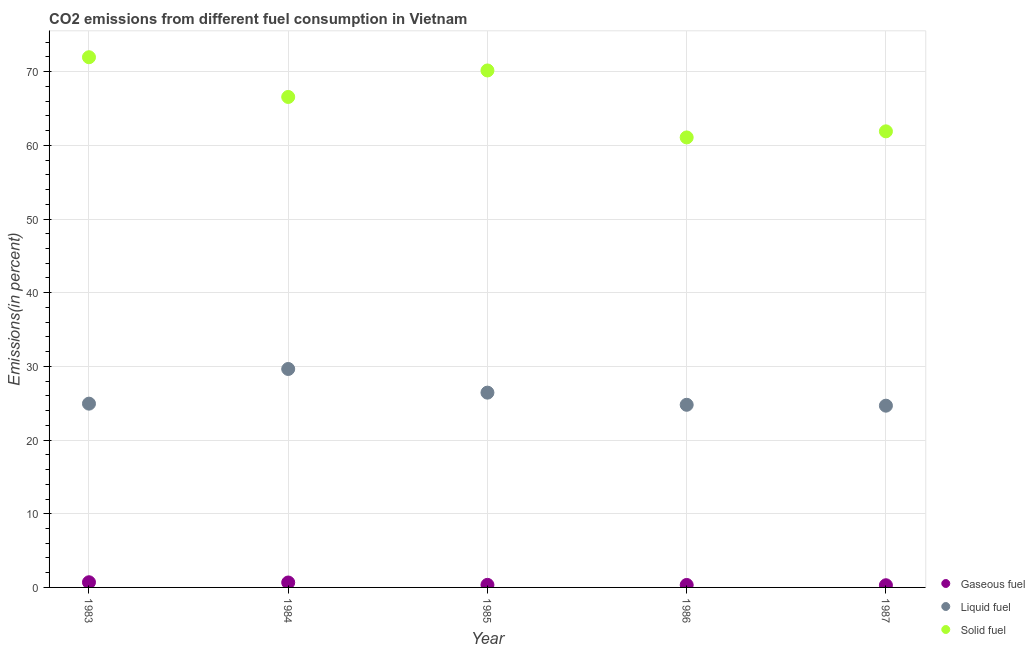How many different coloured dotlines are there?
Make the answer very short. 3. Is the number of dotlines equal to the number of legend labels?
Offer a very short reply. Yes. What is the percentage of gaseous fuel emission in 1985?
Make the answer very short. 0.35. Across all years, what is the maximum percentage of liquid fuel emission?
Make the answer very short. 29.65. Across all years, what is the minimum percentage of liquid fuel emission?
Provide a short and direct response. 24.67. In which year was the percentage of liquid fuel emission maximum?
Your response must be concise. 1984. In which year was the percentage of solid fuel emission minimum?
Offer a terse response. 1986. What is the total percentage of solid fuel emission in the graph?
Ensure brevity in your answer.  331.68. What is the difference between the percentage of gaseous fuel emission in 1985 and that in 1986?
Offer a very short reply. 0.01. What is the difference between the percentage of liquid fuel emission in 1983 and the percentage of solid fuel emission in 1986?
Give a very brief answer. -36.13. What is the average percentage of liquid fuel emission per year?
Offer a terse response. 26.1. In the year 1986, what is the difference between the percentage of gaseous fuel emission and percentage of solid fuel emission?
Make the answer very short. -60.74. What is the ratio of the percentage of gaseous fuel emission in 1986 to that in 1987?
Give a very brief answer. 1.12. Is the difference between the percentage of solid fuel emission in 1983 and 1984 greater than the difference between the percentage of gaseous fuel emission in 1983 and 1984?
Keep it short and to the point. Yes. What is the difference between the highest and the second highest percentage of gaseous fuel emission?
Your answer should be compact. 0.03. What is the difference between the highest and the lowest percentage of liquid fuel emission?
Make the answer very short. 4.98. In how many years, is the percentage of liquid fuel emission greater than the average percentage of liquid fuel emission taken over all years?
Provide a succinct answer. 2. Is the sum of the percentage of liquid fuel emission in 1984 and 1985 greater than the maximum percentage of solid fuel emission across all years?
Give a very brief answer. No. Is it the case that in every year, the sum of the percentage of gaseous fuel emission and percentage of liquid fuel emission is greater than the percentage of solid fuel emission?
Provide a short and direct response. No. How many dotlines are there?
Give a very brief answer. 3. Does the graph contain any zero values?
Your answer should be compact. No. What is the title of the graph?
Provide a short and direct response. CO2 emissions from different fuel consumption in Vietnam. What is the label or title of the Y-axis?
Make the answer very short. Emissions(in percent). What is the Emissions(in percent) in Gaseous fuel in 1983?
Ensure brevity in your answer.  0.7. What is the Emissions(in percent) of Liquid fuel in 1983?
Offer a very short reply. 24.94. What is the Emissions(in percent) in Solid fuel in 1983?
Give a very brief answer. 71.96. What is the Emissions(in percent) of Gaseous fuel in 1984?
Offer a very short reply. 0.67. What is the Emissions(in percent) of Liquid fuel in 1984?
Your answer should be very brief. 29.65. What is the Emissions(in percent) of Solid fuel in 1984?
Offer a very short reply. 66.57. What is the Emissions(in percent) of Gaseous fuel in 1985?
Make the answer very short. 0.35. What is the Emissions(in percent) in Liquid fuel in 1985?
Your answer should be compact. 26.44. What is the Emissions(in percent) of Solid fuel in 1985?
Make the answer very short. 70.17. What is the Emissions(in percent) of Gaseous fuel in 1986?
Keep it short and to the point. 0.33. What is the Emissions(in percent) in Liquid fuel in 1986?
Give a very brief answer. 24.79. What is the Emissions(in percent) in Solid fuel in 1986?
Make the answer very short. 61.08. What is the Emissions(in percent) of Gaseous fuel in 1987?
Make the answer very short. 0.3. What is the Emissions(in percent) in Liquid fuel in 1987?
Provide a succinct answer. 24.67. What is the Emissions(in percent) of Solid fuel in 1987?
Your response must be concise. 61.9. Across all years, what is the maximum Emissions(in percent) of Gaseous fuel?
Your response must be concise. 0.7. Across all years, what is the maximum Emissions(in percent) in Liquid fuel?
Offer a very short reply. 29.65. Across all years, what is the maximum Emissions(in percent) in Solid fuel?
Keep it short and to the point. 71.96. Across all years, what is the minimum Emissions(in percent) of Gaseous fuel?
Offer a very short reply. 0.3. Across all years, what is the minimum Emissions(in percent) of Liquid fuel?
Provide a short and direct response. 24.67. Across all years, what is the minimum Emissions(in percent) of Solid fuel?
Keep it short and to the point. 61.08. What is the total Emissions(in percent) in Gaseous fuel in the graph?
Make the answer very short. 2.35. What is the total Emissions(in percent) of Liquid fuel in the graph?
Your answer should be very brief. 130.49. What is the total Emissions(in percent) of Solid fuel in the graph?
Your answer should be compact. 331.68. What is the difference between the Emissions(in percent) of Gaseous fuel in 1983 and that in 1984?
Your response must be concise. 0.03. What is the difference between the Emissions(in percent) in Liquid fuel in 1983 and that in 1984?
Offer a terse response. -4.71. What is the difference between the Emissions(in percent) of Solid fuel in 1983 and that in 1984?
Your response must be concise. 5.39. What is the difference between the Emissions(in percent) of Gaseous fuel in 1983 and that in 1985?
Provide a short and direct response. 0.36. What is the difference between the Emissions(in percent) in Liquid fuel in 1983 and that in 1985?
Your answer should be very brief. -1.49. What is the difference between the Emissions(in percent) of Solid fuel in 1983 and that in 1985?
Make the answer very short. 1.8. What is the difference between the Emissions(in percent) of Gaseous fuel in 1983 and that in 1986?
Your response must be concise. 0.37. What is the difference between the Emissions(in percent) in Liquid fuel in 1983 and that in 1986?
Offer a terse response. 0.15. What is the difference between the Emissions(in percent) of Solid fuel in 1983 and that in 1986?
Keep it short and to the point. 10.89. What is the difference between the Emissions(in percent) of Gaseous fuel in 1983 and that in 1987?
Provide a short and direct response. 0.41. What is the difference between the Emissions(in percent) of Liquid fuel in 1983 and that in 1987?
Offer a very short reply. 0.27. What is the difference between the Emissions(in percent) in Solid fuel in 1983 and that in 1987?
Keep it short and to the point. 10.06. What is the difference between the Emissions(in percent) in Gaseous fuel in 1984 and that in 1985?
Make the answer very short. 0.32. What is the difference between the Emissions(in percent) in Liquid fuel in 1984 and that in 1985?
Provide a succinct answer. 3.21. What is the difference between the Emissions(in percent) in Solid fuel in 1984 and that in 1985?
Your response must be concise. -3.6. What is the difference between the Emissions(in percent) of Gaseous fuel in 1984 and that in 1986?
Give a very brief answer. 0.34. What is the difference between the Emissions(in percent) in Liquid fuel in 1984 and that in 1986?
Give a very brief answer. 4.86. What is the difference between the Emissions(in percent) in Solid fuel in 1984 and that in 1986?
Give a very brief answer. 5.49. What is the difference between the Emissions(in percent) of Gaseous fuel in 1984 and that in 1987?
Your answer should be compact. 0.37. What is the difference between the Emissions(in percent) in Liquid fuel in 1984 and that in 1987?
Give a very brief answer. 4.98. What is the difference between the Emissions(in percent) in Solid fuel in 1984 and that in 1987?
Offer a very short reply. 4.67. What is the difference between the Emissions(in percent) of Gaseous fuel in 1985 and that in 1986?
Make the answer very short. 0.01. What is the difference between the Emissions(in percent) in Liquid fuel in 1985 and that in 1986?
Make the answer very short. 1.65. What is the difference between the Emissions(in percent) in Solid fuel in 1985 and that in 1986?
Provide a succinct answer. 9.09. What is the difference between the Emissions(in percent) of Gaseous fuel in 1985 and that in 1987?
Offer a very short reply. 0.05. What is the difference between the Emissions(in percent) in Liquid fuel in 1985 and that in 1987?
Provide a short and direct response. 1.77. What is the difference between the Emissions(in percent) of Solid fuel in 1985 and that in 1987?
Offer a very short reply. 8.26. What is the difference between the Emissions(in percent) in Gaseous fuel in 1986 and that in 1987?
Give a very brief answer. 0.04. What is the difference between the Emissions(in percent) in Liquid fuel in 1986 and that in 1987?
Offer a terse response. 0.12. What is the difference between the Emissions(in percent) of Solid fuel in 1986 and that in 1987?
Your answer should be very brief. -0.83. What is the difference between the Emissions(in percent) of Gaseous fuel in 1983 and the Emissions(in percent) of Liquid fuel in 1984?
Give a very brief answer. -28.95. What is the difference between the Emissions(in percent) of Gaseous fuel in 1983 and the Emissions(in percent) of Solid fuel in 1984?
Your answer should be very brief. -65.87. What is the difference between the Emissions(in percent) in Liquid fuel in 1983 and the Emissions(in percent) in Solid fuel in 1984?
Your answer should be very brief. -41.63. What is the difference between the Emissions(in percent) in Gaseous fuel in 1983 and the Emissions(in percent) in Liquid fuel in 1985?
Your response must be concise. -25.74. What is the difference between the Emissions(in percent) of Gaseous fuel in 1983 and the Emissions(in percent) of Solid fuel in 1985?
Provide a short and direct response. -69.46. What is the difference between the Emissions(in percent) in Liquid fuel in 1983 and the Emissions(in percent) in Solid fuel in 1985?
Your answer should be compact. -45.22. What is the difference between the Emissions(in percent) in Gaseous fuel in 1983 and the Emissions(in percent) in Liquid fuel in 1986?
Ensure brevity in your answer.  -24.09. What is the difference between the Emissions(in percent) of Gaseous fuel in 1983 and the Emissions(in percent) of Solid fuel in 1986?
Give a very brief answer. -60.37. What is the difference between the Emissions(in percent) of Liquid fuel in 1983 and the Emissions(in percent) of Solid fuel in 1986?
Ensure brevity in your answer.  -36.13. What is the difference between the Emissions(in percent) of Gaseous fuel in 1983 and the Emissions(in percent) of Liquid fuel in 1987?
Make the answer very short. -23.97. What is the difference between the Emissions(in percent) in Gaseous fuel in 1983 and the Emissions(in percent) in Solid fuel in 1987?
Ensure brevity in your answer.  -61.2. What is the difference between the Emissions(in percent) in Liquid fuel in 1983 and the Emissions(in percent) in Solid fuel in 1987?
Your answer should be very brief. -36.96. What is the difference between the Emissions(in percent) in Gaseous fuel in 1984 and the Emissions(in percent) in Liquid fuel in 1985?
Your answer should be very brief. -25.77. What is the difference between the Emissions(in percent) in Gaseous fuel in 1984 and the Emissions(in percent) in Solid fuel in 1985?
Make the answer very short. -69.5. What is the difference between the Emissions(in percent) of Liquid fuel in 1984 and the Emissions(in percent) of Solid fuel in 1985?
Your response must be concise. -40.52. What is the difference between the Emissions(in percent) in Gaseous fuel in 1984 and the Emissions(in percent) in Liquid fuel in 1986?
Ensure brevity in your answer.  -24.12. What is the difference between the Emissions(in percent) of Gaseous fuel in 1984 and the Emissions(in percent) of Solid fuel in 1986?
Offer a terse response. -60.41. What is the difference between the Emissions(in percent) in Liquid fuel in 1984 and the Emissions(in percent) in Solid fuel in 1986?
Ensure brevity in your answer.  -31.43. What is the difference between the Emissions(in percent) of Gaseous fuel in 1984 and the Emissions(in percent) of Liquid fuel in 1987?
Keep it short and to the point. -24. What is the difference between the Emissions(in percent) of Gaseous fuel in 1984 and the Emissions(in percent) of Solid fuel in 1987?
Your response must be concise. -61.23. What is the difference between the Emissions(in percent) of Liquid fuel in 1984 and the Emissions(in percent) of Solid fuel in 1987?
Ensure brevity in your answer.  -32.25. What is the difference between the Emissions(in percent) in Gaseous fuel in 1985 and the Emissions(in percent) in Liquid fuel in 1986?
Ensure brevity in your answer.  -24.44. What is the difference between the Emissions(in percent) of Gaseous fuel in 1985 and the Emissions(in percent) of Solid fuel in 1986?
Keep it short and to the point. -60.73. What is the difference between the Emissions(in percent) in Liquid fuel in 1985 and the Emissions(in percent) in Solid fuel in 1986?
Offer a terse response. -34.64. What is the difference between the Emissions(in percent) of Gaseous fuel in 1985 and the Emissions(in percent) of Liquid fuel in 1987?
Your answer should be compact. -24.32. What is the difference between the Emissions(in percent) in Gaseous fuel in 1985 and the Emissions(in percent) in Solid fuel in 1987?
Keep it short and to the point. -61.56. What is the difference between the Emissions(in percent) in Liquid fuel in 1985 and the Emissions(in percent) in Solid fuel in 1987?
Your response must be concise. -35.47. What is the difference between the Emissions(in percent) of Gaseous fuel in 1986 and the Emissions(in percent) of Liquid fuel in 1987?
Give a very brief answer. -24.33. What is the difference between the Emissions(in percent) of Gaseous fuel in 1986 and the Emissions(in percent) of Solid fuel in 1987?
Offer a terse response. -61.57. What is the difference between the Emissions(in percent) in Liquid fuel in 1986 and the Emissions(in percent) in Solid fuel in 1987?
Your answer should be compact. -37.11. What is the average Emissions(in percent) in Gaseous fuel per year?
Offer a terse response. 0.47. What is the average Emissions(in percent) of Liquid fuel per year?
Make the answer very short. 26.1. What is the average Emissions(in percent) of Solid fuel per year?
Ensure brevity in your answer.  66.34. In the year 1983, what is the difference between the Emissions(in percent) of Gaseous fuel and Emissions(in percent) of Liquid fuel?
Your response must be concise. -24.24. In the year 1983, what is the difference between the Emissions(in percent) of Gaseous fuel and Emissions(in percent) of Solid fuel?
Offer a terse response. -71.26. In the year 1983, what is the difference between the Emissions(in percent) in Liquid fuel and Emissions(in percent) in Solid fuel?
Your answer should be very brief. -47.02. In the year 1984, what is the difference between the Emissions(in percent) of Gaseous fuel and Emissions(in percent) of Liquid fuel?
Your response must be concise. -28.98. In the year 1984, what is the difference between the Emissions(in percent) of Gaseous fuel and Emissions(in percent) of Solid fuel?
Offer a very short reply. -65.9. In the year 1984, what is the difference between the Emissions(in percent) in Liquid fuel and Emissions(in percent) in Solid fuel?
Your response must be concise. -36.92. In the year 1985, what is the difference between the Emissions(in percent) of Gaseous fuel and Emissions(in percent) of Liquid fuel?
Give a very brief answer. -26.09. In the year 1985, what is the difference between the Emissions(in percent) in Gaseous fuel and Emissions(in percent) in Solid fuel?
Offer a very short reply. -69.82. In the year 1985, what is the difference between the Emissions(in percent) of Liquid fuel and Emissions(in percent) of Solid fuel?
Make the answer very short. -43.73. In the year 1986, what is the difference between the Emissions(in percent) in Gaseous fuel and Emissions(in percent) in Liquid fuel?
Your answer should be very brief. -24.46. In the year 1986, what is the difference between the Emissions(in percent) of Gaseous fuel and Emissions(in percent) of Solid fuel?
Offer a very short reply. -60.74. In the year 1986, what is the difference between the Emissions(in percent) of Liquid fuel and Emissions(in percent) of Solid fuel?
Provide a short and direct response. -36.29. In the year 1987, what is the difference between the Emissions(in percent) in Gaseous fuel and Emissions(in percent) in Liquid fuel?
Offer a terse response. -24.37. In the year 1987, what is the difference between the Emissions(in percent) of Gaseous fuel and Emissions(in percent) of Solid fuel?
Give a very brief answer. -61.61. In the year 1987, what is the difference between the Emissions(in percent) in Liquid fuel and Emissions(in percent) in Solid fuel?
Provide a succinct answer. -37.24. What is the ratio of the Emissions(in percent) in Gaseous fuel in 1983 to that in 1984?
Provide a short and direct response. 1.05. What is the ratio of the Emissions(in percent) of Liquid fuel in 1983 to that in 1984?
Offer a terse response. 0.84. What is the ratio of the Emissions(in percent) in Solid fuel in 1983 to that in 1984?
Offer a very short reply. 1.08. What is the ratio of the Emissions(in percent) in Gaseous fuel in 1983 to that in 1985?
Make the answer very short. 2.03. What is the ratio of the Emissions(in percent) in Liquid fuel in 1983 to that in 1985?
Give a very brief answer. 0.94. What is the ratio of the Emissions(in percent) in Solid fuel in 1983 to that in 1985?
Your answer should be compact. 1.03. What is the ratio of the Emissions(in percent) of Gaseous fuel in 1983 to that in 1986?
Provide a short and direct response. 2.11. What is the ratio of the Emissions(in percent) of Solid fuel in 1983 to that in 1986?
Your response must be concise. 1.18. What is the ratio of the Emissions(in percent) of Gaseous fuel in 1983 to that in 1987?
Make the answer very short. 2.37. What is the ratio of the Emissions(in percent) of Liquid fuel in 1983 to that in 1987?
Keep it short and to the point. 1.01. What is the ratio of the Emissions(in percent) of Solid fuel in 1983 to that in 1987?
Offer a very short reply. 1.16. What is the ratio of the Emissions(in percent) of Gaseous fuel in 1984 to that in 1985?
Your response must be concise. 1.93. What is the ratio of the Emissions(in percent) in Liquid fuel in 1984 to that in 1985?
Your answer should be compact. 1.12. What is the ratio of the Emissions(in percent) of Solid fuel in 1984 to that in 1985?
Your answer should be very brief. 0.95. What is the ratio of the Emissions(in percent) in Gaseous fuel in 1984 to that in 1986?
Your response must be concise. 2. What is the ratio of the Emissions(in percent) of Liquid fuel in 1984 to that in 1986?
Your response must be concise. 1.2. What is the ratio of the Emissions(in percent) of Solid fuel in 1984 to that in 1986?
Give a very brief answer. 1.09. What is the ratio of the Emissions(in percent) in Gaseous fuel in 1984 to that in 1987?
Your answer should be compact. 2.25. What is the ratio of the Emissions(in percent) in Liquid fuel in 1984 to that in 1987?
Make the answer very short. 1.2. What is the ratio of the Emissions(in percent) of Solid fuel in 1984 to that in 1987?
Your answer should be compact. 1.08. What is the ratio of the Emissions(in percent) in Gaseous fuel in 1985 to that in 1986?
Provide a short and direct response. 1.04. What is the ratio of the Emissions(in percent) of Liquid fuel in 1985 to that in 1986?
Make the answer very short. 1.07. What is the ratio of the Emissions(in percent) in Solid fuel in 1985 to that in 1986?
Provide a short and direct response. 1.15. What is the ratio of the Emissions(in percent) in Gaseous fuel in 1985 to that in 1987?
Offer a very short reply. 1.17. What is the ratio of the Emissions(in percent) in Liquid fuel in 1985 to that in 1987?
Provide a succinct answer. 1.07. What is the ratio of the Emissions(in percent) in Solid fuel in 1985 to that in 1987?
Make the answer very short. 1.13. What is the ratio of the Emissions(in percent) of Gaseous fuel in 1986 to that in 1987?
Ensure brevity in your answer.  1.12. What is the ratio of the Emissions(in percent) of Liquid fuel in 1986 to that in 1987?
Your response must be concise. 1. What is the ratio of the Emissions(in percent) in Solid fuel in 1986 to that in 1987?
Offer a very short reply. 0.99. What is the difference between the highest and the second highest Emissions(in percent) in Gaseous fuel?
Provide a succinct answer. 0.03. What is the difference between the highest and the second highest Emissions(in percent) in Liquid fuel?
Provide a succinct answer. 3.21. What is the difference between the highest and the second highest Emissions(in percent) in Solid fuel?
Your answer should be compact. 1.8. What is the difference between the highest and the lowest Emissions(in percent) of Gaseous fuel?
Your response must be concise. 0.41. What is the difference between the highest and the lowest Emissions(in percent) of Liquid fuel?
Your answer should be very brief. 4.98. What is the difference between the highest and the lowest Emissions(in percent) of Solid fuel?
Ensure brevity in your answer.  10.89. 